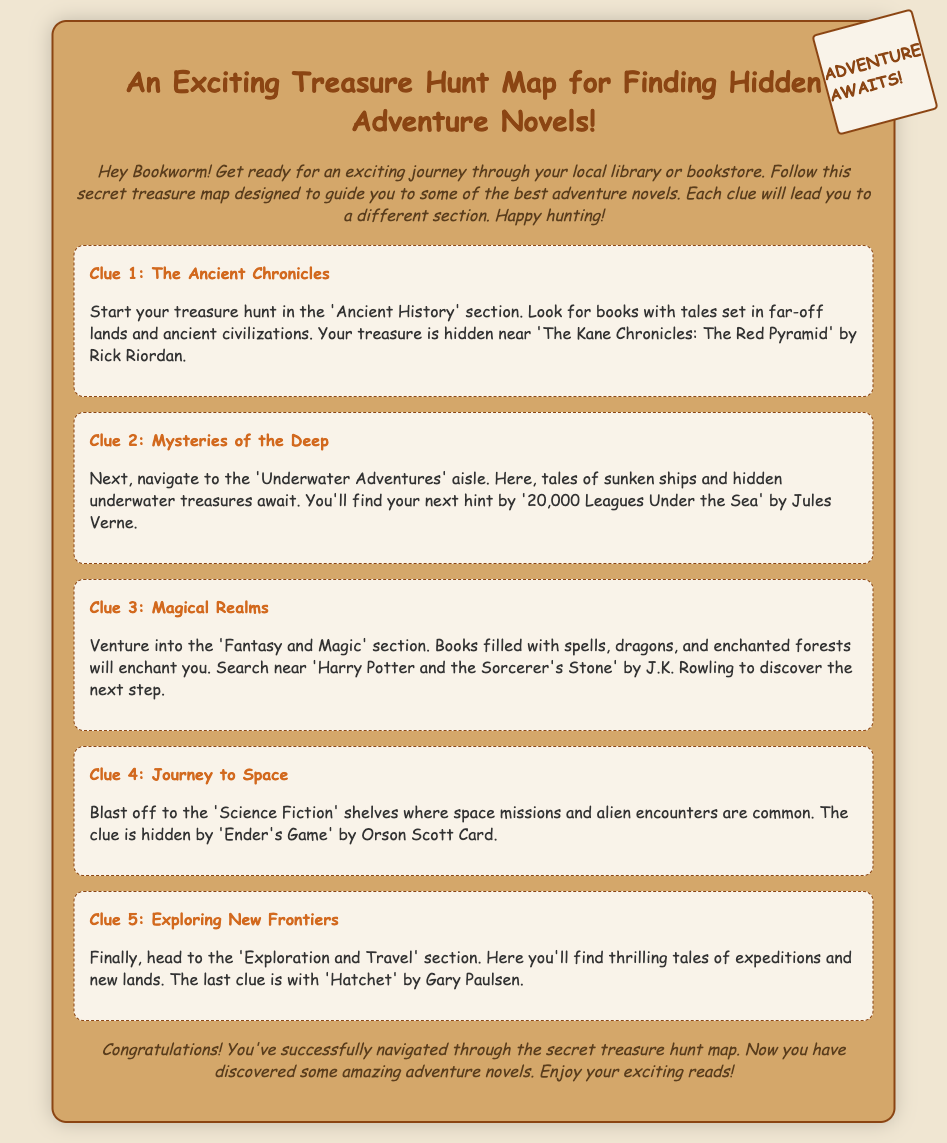what is the title of the treasure hunt map? The title of the treasure hunt map is mentioned at the top of the document.
Answer: An Exciting Treasure Hunt Map for Finding Hidden Adventure Novels! where is the first clue hidden? This information is derived from the first clue's description in the document.
Answer: Near 'The Kane Chronicles: The Red Pyramid' by Rick Riordan which genre is the second clue related to? The genre for the second clue is specified in its section.
Answer: Underwater Adventures what book is associated with the third clue? The specific book mentioned in the third clue can be found in the document.
Answer: Harry Potter and the Sorcerer's Stone how many clues are there in total? The total number of clues can be counted from the sections in the document.
Answer: Five what is the final clue related to? The description of the final clue in the document identifies this.
Answer: Exploring New Frontiers what type of document is this? The structure and content indicate what kind of document it is.
Answer: Treasure hunt map what should you do after finding all the clues? The conclusion section provides guidance on what to do next.
Answer: Enjoy your exciting reads! 